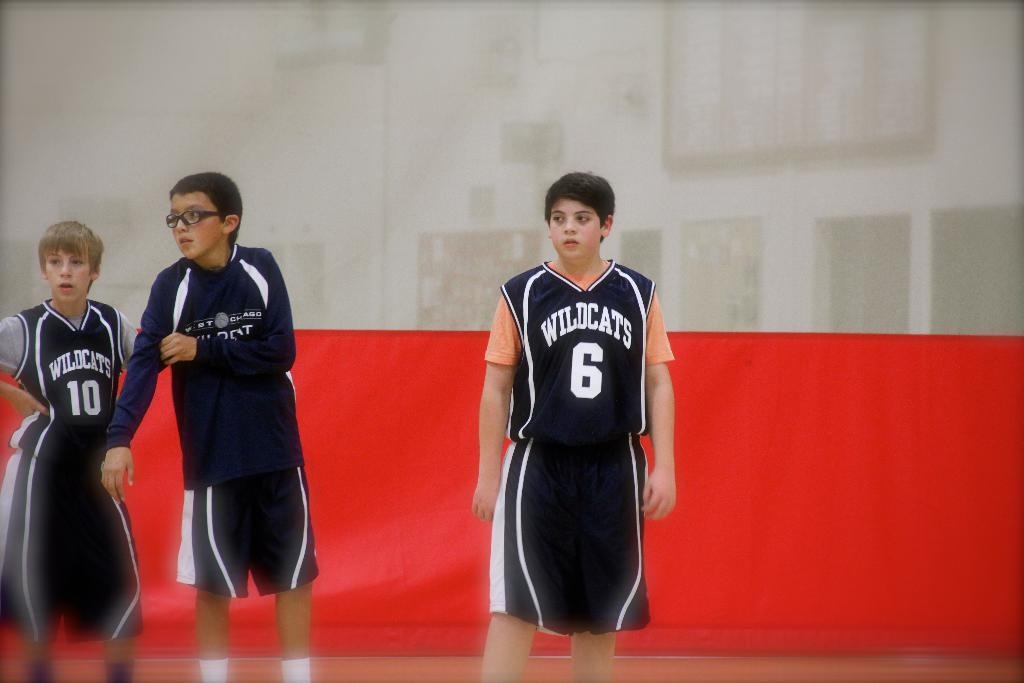Provide a one-sentence caption for the provided image. wildcats basketball players watching the basketball game number 6. 